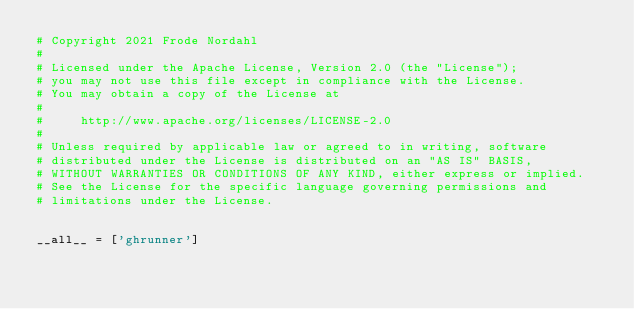<code> <loc_0><loc_0><loc_500><loc_500><_Python_># Copyright 2021 Frode Nordahl
#
# Licensed under the Apache License, Version 2.0 (the "License");
# you may not use this file except in compliance with the License.
# You may obtain a copy of the License at
#
#     http://www.apache.org/licenses/LICENSE-2.0
#
# Unless required by applicable law or agreed to in writing, software
# distributed under the License is distributed on an "AS IS" BASIS,
# WITHOUT WARRANTIES OR CONDITIONS OF ANY KIND, either express or implied.
# See the License for the specific language governing permissions and
# limitations under the License.


__all__ = ['ghrunner']
</code> 